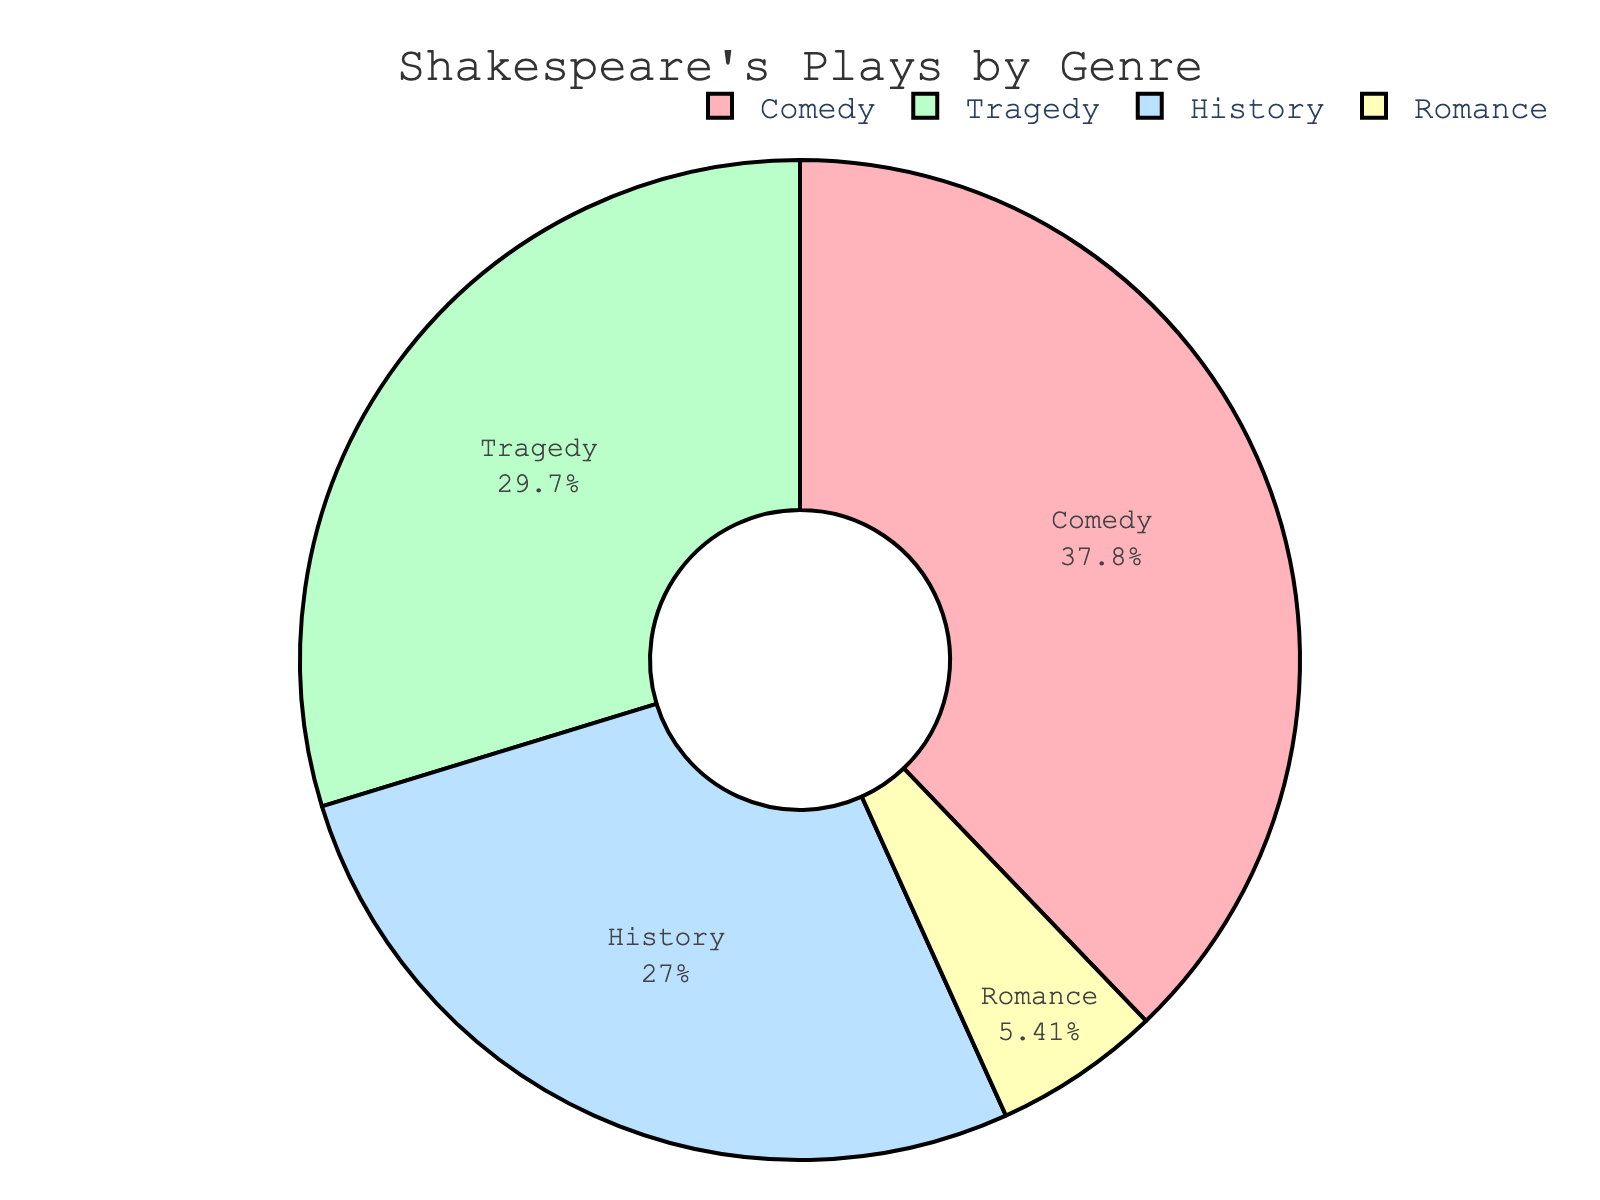What percentage of Shakespeare's plays are comedies? The figure shows a pie chart with different genres. The slice labeled "Comedy" is associated with the percentage 37.8%
Answer: 37.8% Which genre has the lowest percentage of plays? By observing the pie chart, the smallest slice is labeled "Romance" with 5.4%
Answer: Romance How much more percentage does Comedy have compared to History? The pie chart shows Comedy at 37.8% and History at 27.0%. The difference is calculated as 37.8 - 27.0 = 10.8%
Answer: 10.8% What is the combined percentage of Tragedy and History plays? The pie chart has Tragedy at 29.7% and History at 27.0%. Their combined percentage is 29.7 + 27.0 = 56.7%
Answer: 56.7% Which genre has the highest percentage, and how does it compare to the second highest? Comedy has the highest percentage at 37.8%, and Tragedy is the second highest at 29.7%. Comparing these, 37.8 - 29.7 = 8.1%
Answer: Comedy is 8.1% more than Tragedy What is the average percentage of Comedy and Tragedy plays? Comedy is 37.8% and Tragedy is 29.7%. The average is (37.8 + 29.7) / 2 = 33.75%
Answer: 33.75% Is the percentage of Tragedy plays more than twice the percentage of Romance plays? Tragedy is 29.7% and Romance is 5.4%. Twice Romance's percentage is 2 * 5.4 = 10.8%. Since 29.7 > 10.8, Tragedy is indeed more than twice
Answer: Yes If you sum the percentages of Comedy, History, and Romance, what do you get? Comedy is 37.8%, History is 27.0%, and Romance is 5.4%. Summing these gives 37.8 + 27.0 + 5.4 = 70.2%
Answer: 70.2% Which slice in the pie chart is represented by a green color? Observing the color coding in the pie chart, History is represented by green
Answer: History 